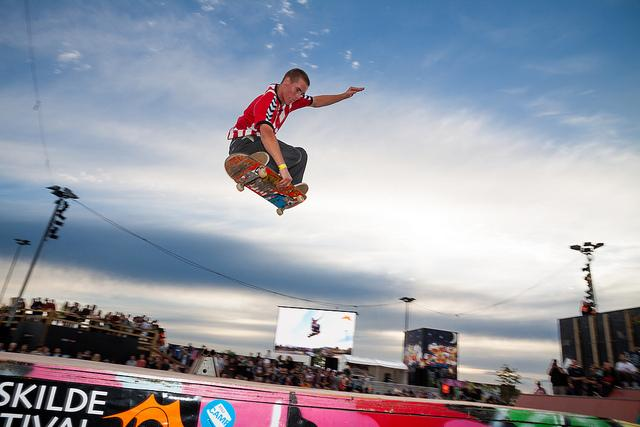What is the name of the trick the man in red is performing?

Choices:
A) manual
B) grab
C) fakie
D) grind grab 